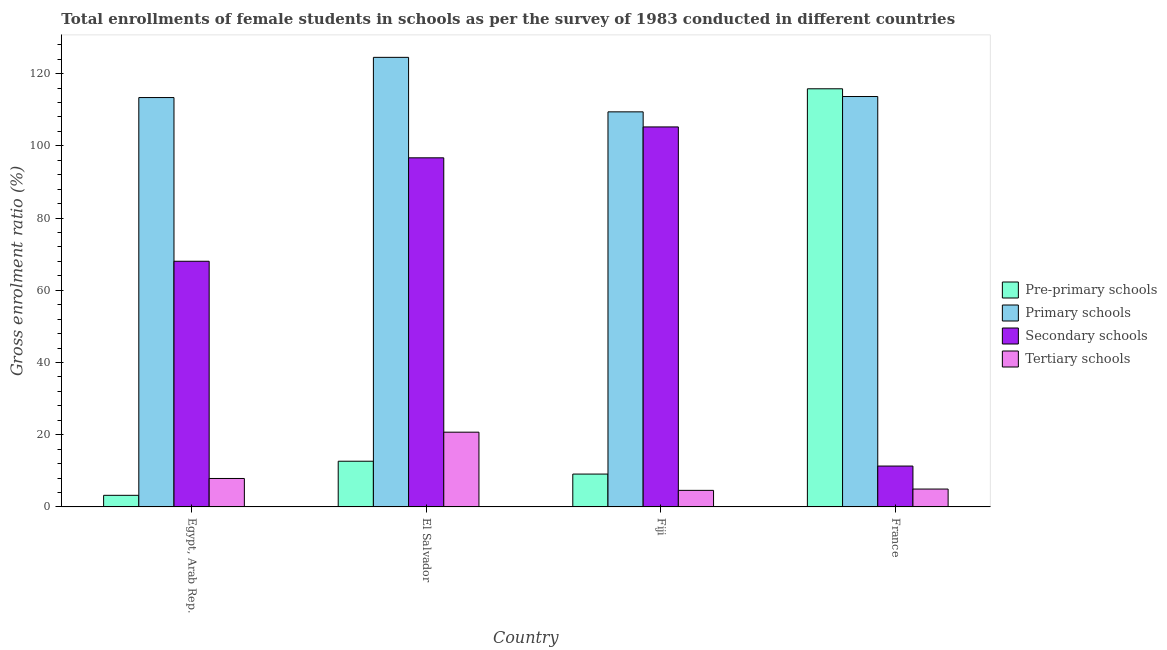How many different coloured bars are there?
Offer a very short reply. 4. Are the number of bars on each tick of the X-axis equal?
Ensure brevity in your answer.  Yes. How many bars are there on the 3rd tick from the left?
Offer a very short reply. 4. How many bars are there on the 3rd tick from the right?
Offer a terse response. 4. What is the label of the 3rd group of bars from the left?
Offer a very short reply. Fiji. What is the gross enrolment ratio(female) in primary schools in Fiji?
Your response must be concise. 109.41. Across all countries, what is the maximum gross enrolment ratio(female) in tertiary schools?
Your answer should be compact. 20.7. Across all countries, what is the minimum gross enrolment ratio(female) in tertiary schools?
Ensure brevity in your answer.  4.59. In which country was the gross enrolment ratio(female) in secondary schools maximum?
Make the answer very short. Fiji. In which country was the gross enrolment ratio(female) in tertiary schools minimum?
Make the answer very short. Fiji. What is the total gross enrolment ratio(female) in secondary schools in the graph?
Your response must be concise. 281.26. What is the difference between the gross enrolment ratio(female) in pre-primary schools in Egypt, Arab Rep. and that in Fiji?
Your response must be concise. -5.88. What is the difference between the gross enrolment ratio(female) in pre-primary schools in Egypt, Arab Rep. and the gross enrolment ratio(female) in primary schools in France?
Give a very brief answer. -110.44. What is the average gross enrolment ratio(female) in pre-primary schools per country?
Provide a short and direct response. 35.19. What is the difference between the gross enrolment ratio(female) in primary schools and gross enrolment ratio(female) in pre-primary schools in El Salvador?
Your answer should be compact. 111.84. In how many countries, is the gross enrolment ratio(female) in primary schools greater than 68 %?
Provide a succinct answer. 4. What is the ratio of the gross enrolment ratio(female) in pre-primary schools in El Salvador to that in France?
Provide a short and direct response. 0.11. Is the gross enrolment ratio(female) in secondary schools in Egypt, Arab Rep. less than that in Fiji?
Offer a terse response. Yes. What is the difference between the highest and the second highest gross enrolment ratio(female) in pre-primary schools?
Keep it short and to the point. 103.14. What is the difference between the highest and the lowest gross enrolment ratio(female) in primary schools?
Provide a short and direct response. 15.09. In how many countries, is the gross enrolment ratio(female) in secondary schools greater than the average gross enrolment ratio(female) in secondary schools taken over all countries?
Ensure brevity in your answer.  2. Is it the case that in every country, the sum of the gross enrolment ratio(female) in primary schools and gross enrolment ratio(female) in secondary schools is greater than the sum of gross enrolment ratio(female) in pre-primary schools and gross enrolment ratio(female) in tertiary schools?
Your response must be concise. Yes. What does the 2nd bar from the left in El Salvador represents?
Give a very brief answer. Primary schools. What does the 3rd bar from the right in Egypt, Arab Rep. represents?
Your response must be concise. Primary schools. Are all the bars in the graph horizontal?
Your response must be concise. No. How many countries are there in the graph?
Give a very brief answer. 4. What is the difference between two consecutive major ticks on the Y-axis?
Ensure brevity in your answer.  20. Does the graph contain any zero values?
Keep it short and to the point. No. How are the legend labels stacked?
Offer a terse response. Vertical. What is the title of the graph?
Your response must be concise. Total enrollments of female students in schools as per the survey of 1983 conducted in different countries. What is the label or title of the Y-axis?
Keep it short and to the point. Gross enrolment ratio (%). What is the Gross enrolment ratio (%) of Pre-primary schools in Egypt, Arab Rep.?
Your answer should be very brief. 3.21. What is the Gross enrolment ratio (%) of Primary schools in Egypt, Arab Rep.?
Your answer should be very brief. 113.36. What is the Gross enrolment ratio (%) of Secondary schools in Egypt, Arab Rep.?
Provide a succinct answer. 68.03. What is the Gross enrolment ratio (%) of Tertiary schools in Egypt, Arab Rep.?
Keep it short and to the point. 7.88. What is the Gross enrolment ratio (%) of Pre-primary schools in El Salvador?
Your response must be concise. 12.65. What is the Gross enrolment ratio (%) in Primary schools in El Salvador?
Offer a terse response. 124.5. What is the Gross enrolment ratio (%) in Secondary schools in El Salvador?
Ensure brevity in your answer.  96.68. What is the Gross enrolment ratio (%) of Tertiary schools in El Salvador?
Give a very brief answer. 20.7. What is the Gross enrolment ratio (%) in Pre-primary schools in Fiji?
Your answer should be very brief. 9.1. What is the Gross enrolment ratio (%) of Primary schools in Fiji?
Make the answer very short. 109.41. What is the Gross enrolment ratio (%) of Secondary schools in Fiji?
Give a very brief answer. 105.23. What is the Gross enrolment ratio (%) of Tertiary schools in Fiji?
Provide a short and direct response. 4.59. What is the Gross enrolment ratio (%) of Pre-primary schools in France?
Give a very brief answer. 115.8. What is the Gross enrolment ratio (%) of Primary schools in France?
Make the answer very short. 113.65. What is the Gross enrolment ratio (%) of Secondary schools in France?
Make the answer very short. 11.32. What is the Gross enrolment ratio (%) of Tertiary schools in France?
Your answer should be compact. 4.95. Across all countries, what is the maximum Gross enrolment ratio (%) in Pre-primary schools?
Offer a very short reply. 115.8. Across all countries, what is the maximum Gross enrolment ratio (%) in Primary schools?
Your response must be concise. 124.5. Across all countries, what is the maximum Gross enrolment ratio (%) in Secondary schools?
Keep it short and to the point. 105.23. Across all countries, what is the maximum Gross enrolment ratio (%) in Tertiary schools?
Provide a succinct answer. 20.7. Across all countries, what is the minimum Gross enrolment ratio (%) in Pre-primary schools?
Ensure brevity in your answer.  3.21. Across all countries, what is the minimum Gross enrolment ratio (%) in Primary schools?
Make the answer very short. 109.41. Across all countries, what is the minimum Gross enrolment ratio (%) of Secondary schools?
Keep it short and to the point. 11.32. Across all countries, what is the minimum Gross enrolment ratio (%) in Tertiary schools?
Your answer should be compact. 4.59. What is the total Gross enrolment ratio (%) of Pre-primary schools in the graph?
Make the answer very short. 140.76. What is the total Gross enrolment ratio (%) of Primary schools in the graph?
Your answer should be compact. 460.92. What is the total Gross enrolment ratio (%) of Secondary schools in the graph?
Offer a terse response. 281.26. What is the total Gross enrolment ratio (%) in Tertiary schools in the graph?
Make the answer very short. 38.11. What is the difference between the Gross enrolment ratio (%) of Pre-primary schools in Egypt, Arab Rep. and that in El Salvador?
Keep it short and to the point. -9.44. What is the difference between the Gross enrolment ratio (%) of Primary schools in Egypt, Arab Rep. and that in El Salvador?
Give a very brief answer. -11.13. What is the difference between the Gross enrolment ratio (%) in Secondary schools in Egypt, Arab Rep. and that in El Salvador?
Ensure brevity in your answer.  -28.65. What is the difference between the Gross enrolment ratio (%) of Tertiary schools in Egypt, Arab Rep. and that in El Salvador?
Your response must be concise. -12.82. What is the difference between the Gross enrolment ratio (%) in Pre-primary schools in Egypt, Arab Rep. and that in Fiji?
Offer a very short reply. -5.88. What is the difference between the Gross enrolment ratio (%) of Primary schools in Egypt, Arab Rep. and that in Fiji?
Provide a short and direct response. 3.96. What is the difference between the Gross enrolment ratio (%) of Secondary schools in Egypt, Arab Rep. and that in Fiji?
Provide a short and direct response. -37.2. What is the difference between the Gross enrolment ratio (%) in Tertiary schools in Egypt, Arab Rep. and that in Fiji?
Keep it short and to the point. 3.29. What is the difference between the Gross enrolment ratio (%) in Pre-primary schools in Egypt, Arab Rep. and that in France?
Your answer should be compact. -112.58. What is the difference between the Gross enrolment ratio (%) of Primary schools in Egypt, Arab Rep. and that in France?
Your answer should be very brief. -0.29. What is the difference between the Gross enrolment ratio (%) of Secondary schools in Egypt, Arab Rep. and that in France?
Make the answer very short. 56.71. What is the difference between the Gross enrolment ratio (%) of Tertiary schools in Egypt, Arab Rep. and that in France?
Your answer should be compact. 2.93. What is the difference between the Gross enrolment ratio (%) in Pre-primary schools in El Salvador and that in Fiji?
Provide a succinct answer. 3.56. What is the difference between the Gross enrolment ratio (%) in Primary schools in El Salvador and that in Fiji?
Give a very brief answer. 15.09. What is the difference between the Gross enrolment ratio (%) of Secondary schools in El Salvador and that in Fiji?
Your response must be concise. -8.55. What is the difference between the Gross enrolment ratio (%) in Tertiary schools in El Salvador and that in Fiji?
Your answer should be compact. 16.11. What is the difference between the Gross enrolment ratio (%) of Pre-primary schools in El Salvador and that in France?
Give a very brief answer. -103.14. What is the difference between the Gross enrolment ratio (%) in Primary schools in El Salvador and that in France?
Offer a very short reply. 10.85. What is the difference between the Gross enrolment ratio (%) of Secondary schools in El Salvador and that in France?
Give a very brief answer. 85.36. What is the difference between the Gross enrolment ratio (%) of Tertiary schools in El Salvador and that in France?
Your answer should be very brief. 15.75. What is the difference between the Gross enrolment ratio (%) in Pre-primary schools in Fiji and that in France?
Ensure brevity in your answer.  -106.7. What is the difference between the Gross enrolment ratio (%) in Primary schools in Fiji and that in France?
Make the answer very short. -4.24. What is the difference between the Gross enrolment ratio (%) in Secondary schools in Fiji and that in France?
Make the answer very short. 93.91. What is the difference between the Gross enrolment ratio (%) in Tertiary schools in Fiji and that in France?
Make the answer very short. -0.36. What is the difference between the Gross enrolment ratio (%) of Pre-primary schools in Egypt, Arab Rep. and the Gross enrolment ratio (%) of Primary schools in El Salvador?
Offer a terse response. -121.28. What is the difference between the Gross enrolment ratio (%) in Pre-primary schools in Egypt, Arab Rep. and the Gross enrolment ratio (%) in Secondary schools in El Salvador?
Ensure brevity in your answer.  -93.46. What is the difference between the Gross enrolment ratio (%) of Pre-primary schools in Egypt, Arab Rep. and the Gross enrolment ratio (%) of Tertiary schools in El Salvador?
Keep it short and to the point. -17.49. What is the difference between the Gross enrolment ratio (%) of Primary schools in Egypt, Arab Rep. and the Gross enrolment ratio (%) of Secondary schools in El Salvador?
Your answer should be compact. 16.69. What is the difference between the Gross enrolment ratio (%) in Primary schools in Egypt, Arab Rep. and the Gross enrolment ratio (%) in Tertiary schools in El Salvador?
Your answer should be very brief. 92.66. What is the difference between the Gross enrolment ratio (%) in Secondary schools in Egypt, Arab Rep. and the Gross enrolment ratio (%) in Tertiary schools in El Salvador?
Your response must be concise. 47.33. What is the difference between the Gross enrolment ratio (%) in Pre-primary schools in Egypt, Arab Rep. and the Gross enrolment ratio (%) in Primary schools in Fiji?
Offer a terse response. -106.19. What is the difference between the Gross enrolment ratio (%) of Pre-primary schools in Egypt, Arab Rep. and the Gross enrolment ratio (%) of Secondary schools in Fiji?
Your response must be concise. -102.02. What is the difference between the Gross enrolment ratio (%) in Pre-primary schools in Egypt, Arab Rep. and the Gross enrolment ratio (%) in Tertiary schools in Fiji?
Ensure brevity in your answer.  -1.37. What is the difference between the Gross enrolment ratio (%) of Primary schools in Egypt, Arab Rep. and the Gross enrolment ratio (%) of Secondary schools in Fiji?
Ensure brevity in your answer.  8.13. What is the difference between the Gross enrolment ratio (%) of Primary schools in Egypt, Arab Rep. and the Gross enrolment ratio (%) of Tertiary schools in Fiji?
Keep it short and to the point. 108.78. What is the difference between the Gross enrolment ratio (%) of Secondary schools in Egypt, Arab Rep. and the Gross enrolment ratio (%) of Tertiary schools in Fiji?
Make the answer very short. 63.44. What is the difference between the Gross enrolment ratio (%) of Pre-primary schools in Egypt, Arab Rep. and the Gross enrolment ratio (%) of Primary schools in France?
Your answer should be very brief. -110.44. What is the difference between the Gross enrolment ratio (%) in Pre-primary schools in Egypt, Arab Rep. and the Gross enrolment ratio (%) in Secondary schools in France?
Ensure brevity in your answer.  -8.1. What is the difference between the Gross enrolment ratio (%) in Pre-primary schools in Egypt, Arab Rep. and the Gross enrolment ratio (%) in Tertiary schools in France?
Offer a terse response. -1.73. What is the difference between the Gross enrolment ratio (%) of Primary schools in Egypt, Arab Rep. and the Gross enrolment ratio (%) of Secondary schools in France?
Your response must be concise. 102.05. What is the difference between the Gross enrolment ratio (%) of Primary schools in Egypt, Arab Rep. and the Gross enrolment ratio (%) of Tertiary schools in France?
Your response must be concise. 108.42. What is the difference between the Gross enrolment ratio (%) of Secondary schools in Egypt, Arab Rep. and the Gross enrolment ratio (%) of Tertiary schools in France?
Provide a succinct answer. 63.08. What is the difference between the Gross enrolment ratio (%) of Pre-primary schools in El Salvador and the Gross enrolment ratio (%) of Primary schools in Fiji?
Your answer should be compact. -96.75. What is the difference between the Gross enrolment ratio (%) of Pre-primary schools in El Salvador and the Gross enrolment ratio (%) of Secondary schools in Fiji?
Make the answer very short. -92.58. What is the difference between the Gross enrolment ratio (%) of Pre-primary schools in El Salvador and the Gross enrolment ratio (%) of Tertiary schools in Fiji?
Offer a terse response. 8.07. What is the difference between the Gross enrolment ratio (%) of Primary schools in El Salvador and the Gross enrolment ratio (%) of Secondary schools in Fiji?
Give a very brief answer. 19.27. What is the difference between the Gross enrolment ratio (%) in Primary schools in El Salvador and the Gross enrolment ratio (%) in Tertiary schools in Fiji?
Provide a succinct answer. 119.91. What is the difference between the Gross enrolment ratio (%) in Secondary schools in El Salvador and the Gross enrolment ratio (%) in Tertiary schools in Fiji?
Provide a succinct answer. 92.09. What is the difference between the Gross enrolment ratio (%) of Pre-primary schools in El Salvador and the Gross enrolment ratio (%) of Primary schools in France?
Keep it short and to the point. -101. What is the difference between the Gross enrolment ratio (%) in Pre-primary schools in El Salvador and the Gross enrolment ratio (%) in Secondary schools in France?
Your response must be concise. 1.34. What is the difference between the Gross enrolment ratio (%) of Pre-primary schools in El Salvador and the Gross enrolment ratio (%) of Tertiary schools in France?
Provide a short and direct response. 7.71. What is the difference between the Gross enrolment ratio (%) in Primary schools in El Salvador and the Gross enrolment ratio (%) in Secondary schools in France?
Offer a very short reply. 113.18. What is the difference between the Gross enrolment ratio (%) in Primary schools in El Salvador and the Gross enrolment ratio (%) in Tertiary schools in France?
Ensure brevity in your answer.  119.55. What is the difference between the Gross enrolment ratio (%) in Secondary schools in El Salvador and the Gross enrolment ratio (%) in Tertiary schools in France?
Offer a very short reply. 91.73. What is the difference between the Gross enrolment ratio (%) in Pre-primary schools in Fiji and the Gross enrolment ratio (%) in Primary schools in France?
Provide a short and direct response. -104.55. What is the difference between the Gross enrolment ratio (%) in Pre-primary schools in Fiji and the Gross enrolment ratio (%) in Secondary schools in France?
Give a very brief answer. -2.22. What is the difference between the Gross enrolment ratio (%) of Pre-primary schools in Fiji and the Gross enrolment ratio (%) of Tertiary schools in France?
Keep it short and to the point. 4.15. What is the difference between the Gross enrolment ratio (%) of Primary schools in Fiji and the Gross enrolment ratio (%) of Secondary schools in France?
Provide a short and direct response. 98.09. What is the difference between the Gross enrolment ratio (%) of Primary schools in Fiji and the Gross enrolment ratio (%) of Tertiary schools in France?
Your answer should be very brief. 104.46. What is the difference between the Gross enrolment ratio (%) of Secondary schools in Fiji and the Gross enrolment ratio (%) of Tertiary schools in France?
Offer a terse response. 100.28. What is the average Gross enrolment ratio (%) of Pre-primary schools per country?
Provide a short and direct response. 35.19. What is the average Gross enrolment ratio (%) in Primary schools per country?
Your answer should be very brief. 115.23. What is the average Gross enrolment ratio (%) in Secondary schools per country?
Offer a very short reply. 70.32. What is the average Gross enrolment ratio (%) in Tertiary schools per country?
Keep it short and to the point. 9.53. What is the difference between the Gross enrolment ratio (%) of Pre-primary schools and Gross enrolment ratio (%) of Primary schools in Egypt, Arab Rep.?
Provide a short and direct response. -110.15. What is the difference between the Gross enrolment ratio (%) of Pre-primary schools and Gross enrolment ratio (%) of Secondary schools in Egypt, Arab Rep.?
Offer a terse response. -64.82. What is the difference between the Gross enrolment ratio (%) of Pre-primary schools and Gross enrolment ratio (%) of Tertiary schools in Egypt, Arab Rep.?
Your answer should be compact. -4.66. What is the difference between the Gross enrolment ratio (%) in Primary schools and Gross enrolment ratio (%) in Secondary schools in Egypt, Arab Rep.?
Provide a succinct answer. 45.33. What is the difference between the Gross enrolment ratio (%) in Primary schools and Gross enrolment ratio (%) in Tertiary schools in Egypt, Arab Rep.?
Ensure brevity in your answer.  105.49. What is the difference between the Gross enrolment ratio (%) of Secondary schools and Gross enrolment ratio (%) of Tertiary schools in Egypt, Arab Rep.?
Provide a short and direct response. 60.15. What is the difference between the Gross enrolment ratio (%) of Pre-primary schools and Gross enrolment ratio (%) of Primary schools in El Salvador?
Provide a short and direct response. -111.84. What is the difference between the Gross enrolment ratio (%) in Pre-primary schools and Gross enrolment ratio (%) in Secondary schools in El Salvador?
Make the answer very short. -84.02. What is the difference between the Gross enrolment ratio (%) in Pre-primary schools and Gross enrolment ratio (%) in Tertiary schools in El Salvador?
Provide a succinct answer. -8.05. What is the difference between the Gross enrolment ratio (%) in Primary schools and Gross enrolment ratio (%) in Secondary schools in El Salvador?
Ensure brevity in your answer.  27.82. What is the difference between the Gross enrolment ratio (%) in Primary schools and Gross enrolment ratio (%) in Tertiary schools in El Salvador?
Your answer should be compact. 103.8. What is the difference between the Gross enrolment ratio (%) in Secondary schools and Gross enrolment ratio (%) in Tertiary schools in El Salvador?
Give a very brief answer. 75.98. What is the difference between the Gross enrolment ratio (%) in Pre-primary schools and Gross enrolment ratio (%) in Primary schools in Fiji?
Offer a very short reply. -100.31. What is the difference between the Gross enrolment ratio (%) of Pre-primary schools and Gross enrolment ratio (%) of Secondary schools in Fiji?
Provide a short and direct response. -96.13. What is the difference between the Gross enrolment ratio (%) in Pre-primary schools and Gross enrolment ratio (%) in Tertiary schools in Fiji?
Your answer should be very brief. 4.51. What is the difference between the Gross enrolment ratio (%) in Primary schools and Gross enrolment ratio (%) in Secondary schools in Fiji?
Provide a short and direct response. 4.18. What is the difference between the Gross enrolment ratio (%) in Primary schools and Gross enrolment ratio (%) in Tertiary schools in Fiji?
Provide a short and direct response. 104.82. What is the difference between the Gross enrolment ratio (%) of Secondary schools and Gross enrolment ratio (%) of Tertiary schools in Fiji?
Keep it short and to the point. 100.64. What is the difference between the Gross enrolment ratio (%) in Pre-primary schools and Gross enrolment ratio (%) in Primary schools in France?
Offer a very short reply. 2.14. What is the difference between the Gross enrolment ratio (%) in Pre-primary schools and Gross enrolment ratio (%) in Secondary schools in France?
Ensure brevity in your answer.  104.48. What is the difference between the Gross enrolment ratio (%) in Pre-primary schools and Gross enrolment ratio (%) in Tertiary schools in France?
Provide a short and direct response. 110.85. What is the difference between the Gross enrolment ratio (%) of Primary schools and Gross enrolment ratio (%) of Secondary schools in France?
Keep it short and to the point. 102.33. What is the difference between the Gross enrolment ratio (%) of Primary schools and Gross enrolment ratio (%) of Tertiary schools in France?
Ensure brevity in your answer.  108.7. What is the difference between the Gross enrolment ratio (%) in Secondary schools and Gross enrolment ratio (%) in Tertiary schools in France?
Make the answer very short. 6.37. What is the ratio of the Gross enrolment ratio (%) in Pre-primary schools in Egypt, Arab Rep. to that in El Salvador?
Your answer should be compact. 0.25. What is the ratio of the Gross enrolment ratio (%) of Primary schools in Egypt, Arab Rep. to that in El Salvador?
Your answer should be very brief. 0.91. What is the ratio of the Gross enrolment ratio (%) of Secondary schools in Egypt, Arab Rep. to that in El Salvador?
Make the answer very short. 0.7. What is the ratio of the Gross enrolment ratio (%) in Tertiary schools in Egypt, Arab Rep. to that in El Salvador?
Give a very brief answer. 0.38. What is the ratio of the Gross enrolment ratio (%) in Pre-primary schools in Egypt, Arab Rep. to that in Fiji?
Your answer should be compact. 0.35. What is the ratio of the Gross enrolment ratio (%) in Primary schools in Egypt, Arab Rep. to that in Fiji?
Provide a short and direct response. 1.04. What is the ratio of the Gross enrolment ratio (%) in Secondary schools in Egypt, Arab Rep. to that in Fiji?
Offer a terse response. 0.65. What is the ratio of the Gross enrolment ratio (%) in Tertiary schools in Egypt, Arab Rep. to that in Fiji?
Offer a terse response. 1.72. What is the ratio of the Gross enrolment ratio (%) in Pre-primary schools in Egypt, Arab Rep. to that in France?
Provide a short and direct response. 0.03. What is the ratio of the Gross enrolment ratio (%) in Primary schools in Egypt, Arab Rep. to that in France?
Offer a very short reply. 1. What is the ratio of the Gross enrolment ratio (%) of Secondary schools in Egypt, Arab Rep. to that in France?
Keep it short and to the point. 6.01. What is the ratio of the Gross enrolment ratio (%) in Tertiary schools in Egypt, Arab Rep. to that in France?
Offer a terse response. 1.59. What is the ratio of the Gross enrolment ratio (%) of Pre-primary schools in El Salvador to that in Fiji?
Your response must be concise. 1.39. What is the ratio of the Gross enrolment ratio (%) of Primary schools in El Salvador to that in Fiji?
Make the answer very short. 1.14. What is the ratio of the Gross enrolment ratio (%) of Secondary schools in El Salvador to that in Fiji?
Offer a terse response. 0.92. What is the ratio of the Gross enrolment ratio (%) in Tertiary schools in El Salvador to that in Fiji?
Provide a succinct answer. 4.51. What is the ratio of the Gross enrolment ratio (%) of Pre-primary schools in El Salvador to that in France?
Keep it short and to the point. 0.11. What is the ratio of the Gross enrolment ratio (%) of Primary schools in El Salvador to that in France?
Offer a very short reply. 1.1. What is the ratio of the Gross enrolment ratio (%) in Secondary schools in El Salvador to that in France?
Make the answer very short. 8.54. What is the ratio of the Gross enrolment ratio (%) of Tertiary schools in El Salvador to that in France?
Provide a short and direct response. 4.18. What is the ratio of the Gross enrolment ratio (%) of Pre-primary schools in Fiji to that in France?
Keep it short and to the point. 0.08. What is the ratio of the Gross enrolment ratio (%) of Primary schools in Fiji to that in France?
Make the answer very short. 0.96. What is the ratio of the Gross enrolment ratio (%) in Secondary schools in Fiji to that in France?
Keep it short and to the point. 9.3. What is the ratio of the Gross enrolment ratio (%) of Tertiary schools in Fiji to that in France?
Make the answer very short. 0.93. What is the difference between the highest and the second highest Gross enrolment ratio (%) in Pre-primary schools?
Offer a very short reply. 103.14. What is the difference between the highest and the second highest Gross enrolment ratio (%) in Primary schools?
Provide a short and direct response. 10.85. What is the difference between the highest and the second highest Gross enrolment ratio (%) in Secondary schools?
Provide a short and direct response. 8.55. What is the difference between the highest and the second highest Gross enrolment ratio (%) in Tertiary schools?
Ensure brevity in your answer.  12.82. What is the difference between the highest and the lowest Gross enrolment ratio (%) in Pre-primary schools?
Your answer should be very brief. 112.58. What is the difference between the highest and the lowest Gross enrolment ratio (%) of Primary schools?
Your response must be concise. 15.09. What is the difference between the highest and the lowest Gross enrolment ratio (%) in Secondary schools?
Ensure brevity in your answer.  93.91. What is the difference between the highest and the lowest Gross enrolment ratio (%) of Tertiary schools?
Give a very brief answer. 16.11. 